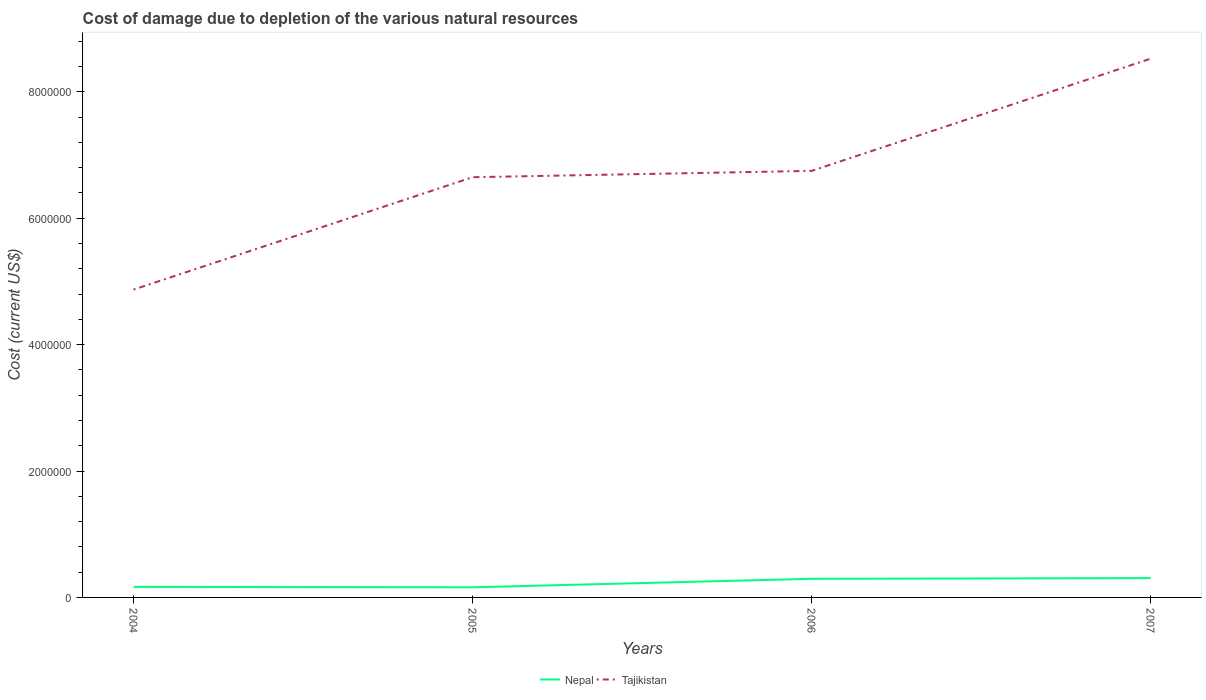How many different coloured lines are there?
Your response must be concise. 2. Across all years, what is the maximum cost of damage caused due to the depletion of various natural resources in Nepal?
Your response must be concise. 1.60e+05. What is the total cost of damage caused due to the depletion of various natural resources in Nepal in the graph?
Provide a succinct answer. -1.34e+05. What is the difference between the highest and the second highest cost of damage caused due to the depletion of various natural resources in Tajikistan?
Give a very brief answer. 3.65e+06. Is the cost of damage caused due to the depletion of various natural resources in Tajikistan strictly greater than the cost of damage caused due to the depletion of various natural resources in Nepal over the years?
Give a very brief answer. No. How many lines are there?
Your answer should be compact. 2. Does the graph contain any zero values?
Provide a short and direct response. No. Where does the legend appear in the graph?
Your response must be concise. Bottom center. What is the title of the graph?
Provide a succinct answer. Cost of damage due to depletion of the various natural resources. Does "Kuwait" appear as one of the legend labels in the graph?
Your response must be concise. No. What is the label or title of the X-axis?
Offer a terse response. Years. What is the label or title of the Y-axis?
Offer a very short reply. Cost (current US$). What is the Cost (current US$) in Nepal in 2004?
Give a very brief answer. 1.67e+05. What is the Cost (current US$) in Tajikistan in 2004?
Offer a very short reply. 4.87e+06. What is the Cost (current US$) in Nepal in 2005?
Offer a terse response. 1.60e+05. What is the Cost (current US$) of Tajikistan in 2005?
Make the answer very short. 6.65e+06. What is the Cost (current US$) of Nepal in 2006?
Offer a very short reply. 2.95e+05. What is the Cost (current US$) of Tajikistan in 2006?
Provide a short and direct response. 6.75e+06. What is the Cost (current US$) of Nepal in 2007?
Your response must be concise. 3.06e+05. What is the Cost (current US$) in Tajikistan in 2007?
Your answer should be compact. 8.52e+06. Across all years, what is the maximum Cost (current US$) in Nepal?
Provide a short and direct response. 3.06e+05. Across all years, what is the maximum Cost (current US$) in Tajikistan?
Offer a terse response. 8.52e+06. Across all years, what is the minimum Cost (current US$) of Nepal?
Provide a short and direct response. 1.60e+05. Across all years, what is the minimum Cost (current US$) of Tajikistan?
Give a very brief answer. 4.87e+06. What is the total Cost (current US$) of Nepal in the graph?
Provide a short and direct response. 9.27e+05. What is the total Cost (current US$) of Tajikistan in the graph?
Offer a very short reply. 2.68e+07. What is the difference between the Cost (current US$) of Nepal in 2004 and that in 2005?
Offer a terse response. 6525.26. What is the difference between the Cost (current US$) of Tajikistan in 2004 and that in 2005?
Keep it short and to the point. -1.78e+06. What is the difference between the Cost (current US$) in Nepal in 2004 and that in 2006?
Offer a very short reply. -1.28e+05. What is the difference between the Cost (current US$) in Tajikistan in 2004 and that in 2006?
Your answer should be compact. -1.88e+06. What is the difference between the Cost (current US$) in Nepal in 2004 and that in 2007?
Offer a very short reply. -1.39e+05. What is the difference between the Cost (current US$) in Tajikistan in 2004 and that in 2007?
Ensure brevity in your answer.  -3.65e+06. What is the difference between the Cost (current US$) in Nepal in 2005 and that in 2006?
Provide a short and direct response. -1.34e+05. What is the difference between the Cost (current US$) of Tajikistan in 2005 and that in 2006?
Give a very brief answer. -1.00e+05. What is the difference between the Cost (current US$) of Nepal in 2005 and that in 2007?
Ensure brevity in your answer.  -1.45e+05. What is the difference between the Cost (current US$) of Tajikistan in 2005 and that in 2007?
Your answer should be compact. -1.88e+06. What is the difference between the Cost (current US$) of Nepal in 2006 and that in 2007?
Provide a short and direct response. -1.12e+04. What is the difference between the Cost (current US$) in Tajikistan in 2006 and that in 2007?
Provide a short and direct response. -1.77e+06. What is the difference between the Cost (current US$) of Nepal in 2004 and the Cost (current US$) of Tajikistan in 2005?
Provide a succinct answer. -6.48e+06. What is the difference between the Cost (current US$) in Nepal in 2004 and the Cost (current US$) in Tajikistan in 2006?
Keep it short and to the point. -6.58e+06. What is the difference between the Cost (current US$) of Nepal in 2004 and the Cost (current US$) of Tajikistan in 2007?
Your response must be concise. -8.36e+06. What is the difference between the Cost (current US$) in Nepal in 2005 and the Cost (current US$) in Tajikistan in 2006?
Offer a terse response. -6.59e+06. What is the difference between the Cost (current US$) of Nepal in 2005 and the Cost (current US$) of Tajikistan in 2007?
Make the answer very short. -8.36e+06. What is the difference between the Cost (current US$) of Nepal in 2006 and the Cost (current US$) of Tajikistan in 2007?
Provide a short and direct response. -8.23e+06. What is the average Cost (current US$) in Nepal per year?
Provide a succinct answer. 2.32e+05. What is the average Cost (current US$) of Tajikistan per year?
Provide a short and direct response. 6.70e+06. In the year 2004, what is the difference between the Cost (current US$) in Nepal and Cost (current US$) in Tajikistan?
Keep it short and to the point. -4.70e+06. In the year 2005, what is the difference between the Cost (current US$) of Nepal and Cost (current US$) of Tajikistan?
Provide a short and direct response. -6.49e+06. In the year 2006, what is the difference between the Cost (current US$) of Nepal and Cost (current US$) of Tajikistan?
Make the answer very short. -6.45e+06. In the year 2007, what is the difference between the Cost (current US$) in Nepal and Cost (current US$) in Tajikistan?
Your response must be concise. -8.22e+06. What is the ratio of the Cost (current US$) in Nepal in 2004 to that in 2005?
Ensure brevity in your answer.  1.04. What is the ratio of the Cost (current US$) of Tajikistan in 2004 to that in 2005?
Keep it short and to the point. 0.73. What is the ratio of the Cost (current US$) in Nepal in 2004 to that in 2006?
Offer a terse response. 0.57. What is the ratio of the Cost (current US$) of Tajikistan in 2004 to that in 2006?
Keep it short and to the point. 0.72. What is the ratio of the Cost (current US$) of Nepal in 2004 to that in 2007?
Your answer should be very brief. 0.55. What is the ratio of the Cost (current US$) in Nepal in 2005 to that in 2006?
Your response must be concise. 0.54. What is the ratio of the Cost (current US$) in Tajikistan in 2005 to that in 2006?
Ensure brevity in your answer.  0.99. What is the ratio of the Cost (current US$) in Nepal in 2005 to that in 2007?
Ensure brevity in your answer.  0.52. What is the ratio of the Cost (current US$) in Tajikistan in 2005 to that in 2007?
Your answer should be compact. 0.78. What is the ratio of the Cost (current US$) in Nepal in 2006 to that in 2007?
Give a very brief answer. 0.96. What is the ratio of the Cost (current US$) of Tajikistan in 2006 to that in 2007?
Your response must be concise. 0.79. What is the difference between the highest and the second highest Cost (current US$) of Nepal?
Provide a short and direct response. 1.12e+04. What is the difference between the highest and the second highest Cost (current US$) of Tajikistan?
Keep it short and to the point. 1.77e+06. What is the difference between the highest and the lowest Cost (current US$) of Nepal?
Provide a succinct answer. 1.45e+05. What is the difference between the highest and the lowest Cost (current US$) of Tajikistan?
Your response must be concise. 3.65e+06. 